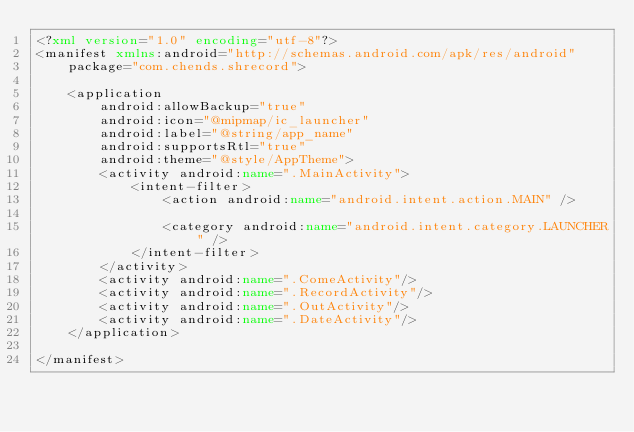Convert code to text. <code><loc_0><loc_0><loc_500><loc_500><_XML_><?xml version="1.0" encoding="utf-8"?>
<manifest xmlns:android="http://schemas.android.com/apk/res/android"
    package="com.chends.shrecord">

    <application
        android:allowBackup="true"
        android:icon="@mipmap/ic_launcher"
        android:label="@string/app_name"
        android:supportsRtl="true"
        android:theme="@style/AppTheme">
        <activity android:name=".MainActivity">
            <intent-filter>
                <action android:name="android.intent.action.MAIN" />

                <category android:name="android.intent.category.LAUNCHER" />
            </intent-filter>
        </activity>
        <activity android:name=".ComeActivity"/>
        <activity android:name=".RecordActivity"/>
        <activity android:name=".OutActivity"/>
        <activity android:name=".DateActivity"/>
    </application>

</manifest></code> 